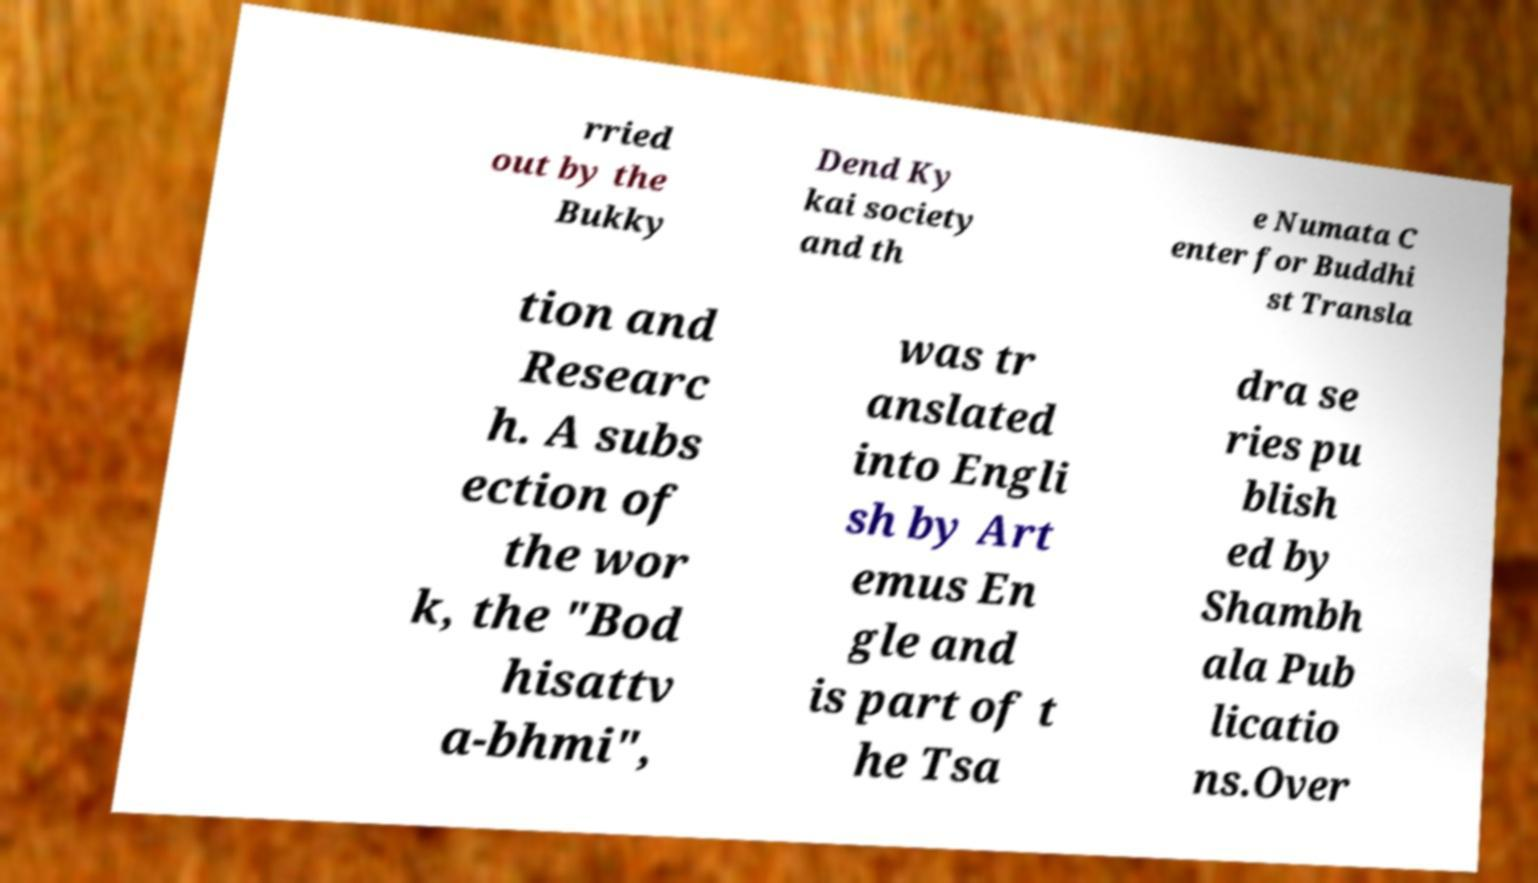There's text embedded in this image that I need extracted. Can you transcribe it verbatim? rried out by the Bukky Dend Ky kai society and th e Numata C enter for Buddhi st Transla tion and Researc h. A subs ection of the wor k, the "Bod hisattv a-bhmi", was tr anslated into Engli sh by Art emus En gle and is part of t he Tsa dra se ries pu blish ed by Shambh ala Pub licatio ns.Over 